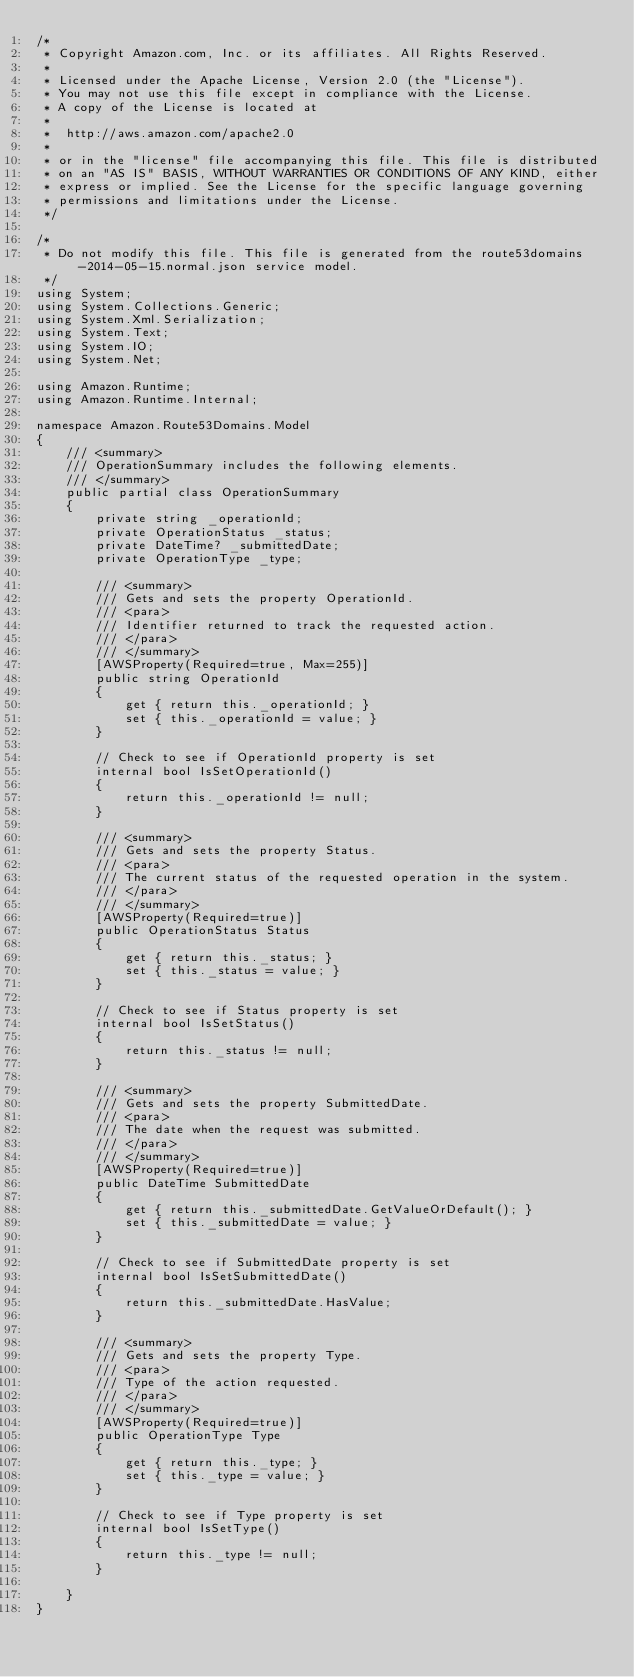<code> <loc_0><loc_0><loc_500><loc_500><_C#_>/*
 * Copyright Amazon.com, Inc. or its affiliates. All Rights Reserved.
 * 
 * Licensed under the Apache License, Version 2.0 (the "License").
 * You may not use this file except in compliance with the License.
 * A copy of the License is located at
 * 
 *  http://aws.amazon.com/apache2.0
 * 
 * or in the "license" file accompanying this file. This file is distributed
 * on an "AS IS" BASIS, WITHOUT WARRANTIES OR CONDITIONS OF ANY KIND, either
 * express or implied. See the License for the specific language governing
 * permissions and limitations under the License.
 */

/*
 * Do not modify this file. This file is generated from the route53domains-2014-05-15.normal.json service model.
 */
using System;
using System.Collections.Generic;
using System.Xml.Serialization;
using System.Text;
using System.IO;
using System.Net;

using Amazon.Runtime;
using Amazon.Runtime.Internal;

namespace Amazon.Route53Domains.Model
{
    /// <summary>
    /// OperationSummary includes the following elements.
    /// </summary>
    public partial class OperationSummary
    {
        private string _operationId;
        private OperationStatus _status;
        private DateTime? _submittedDate;
        private OperationType _type;

        /// <summary>
        /// Gets and sets the property OperationId. 
        /// <para>
        /// Identifier returned to track the requested action.
        /// </para>
        /// </summary>
        [AWSProperty(Required=true, Max=255)]
        public string OperationId
        {
            get { return this._operationId; }
            set { this._operationId = value; }
        }

        // Check to see if OperationId property is set
        internal bool IsSetOperationId()
        {
            return this._operationId != null;
        }

        /// <summary>
        /// Gets and sets the property Status. 
        /// <para>
        /// The current status of the requested operation in the system.
        /// </para>
        /// </summary>
        [AWSProperty(Required=true)]
        public OperationStatus Status
        {
            get { return this._status; }
            set { this._status = value; }
        }

        // Check to see if Status property is set
        internal bool IsSetStatus()
        {
            return this._status != null;
        }

        /// <summary>
        /// Gets and sets the property SubmittedDate. 
        /// <para>
        /// The date when the request was submitted.
        /// </para>
        /// </summary>
        [AWSProperty(Required=true)]
        public DateTime SubmittedDate
        {
            get { return this._submittedDate.GetValueOrDefault(); }
            set { this._submittedDate = value; }
        }

        // Check to see if SubmittedDate property is set
        internal bool IsSetSubmittedDate()
        {
            return this._submittedDate.HasValue; 
        }

        /// <summary>
        /// Gets and sets the property Type. 
        /// <para>
        /// Type of the action requested.
        /// </para>
        /// </summary>
        [AWSProperty(Required=true)]
        public OperationType Type
        {
            get { return this._type; }
            set { this._type = value; }
        }

        // Check to see if Type property is set
        internal bool IsSetType()
        {
            return this._type != null;
        }

    }
}</code> 